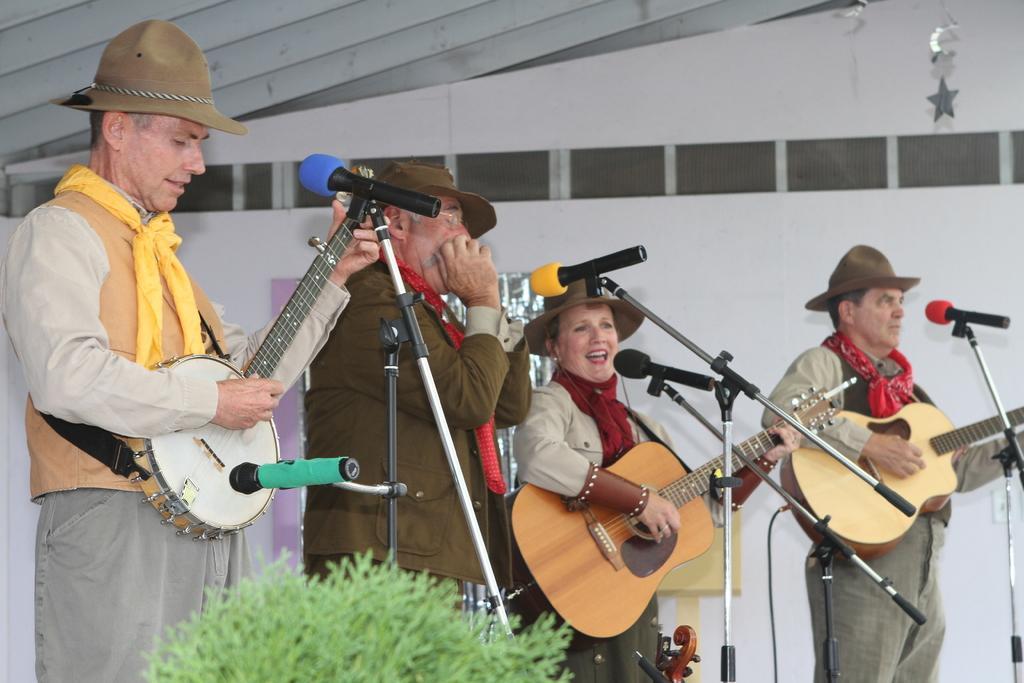Can you describe this image briefly? This person is standing playing musical instrument,this is microphone,this is flower again this woman is playing guitar and in the background there is white color sheet this person is wearing hat. 